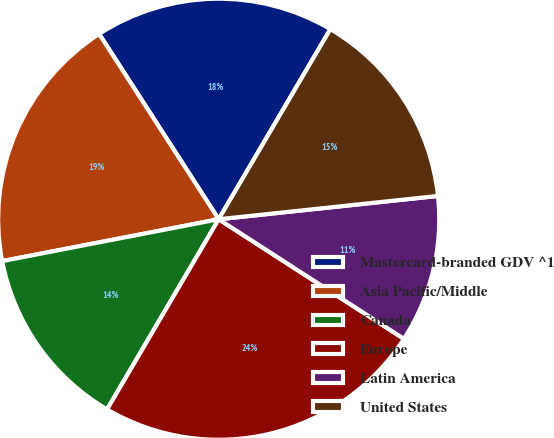Convert chart. <chart><loc_0><loc_0><loc_500><loc_500><pie_chart><fcel>Mastercard-branded GDV ^1<fcel>Asia Pacific/Middle<fcel>Canada<fcel>Europe<fcel>Latin America<fcel>United States<nl><fcel>17.57%<fcel>18.92%<fcel>13.51%<fcel>24.32%<fcel>10.81%<fcel>14.86%<nl></chart> 